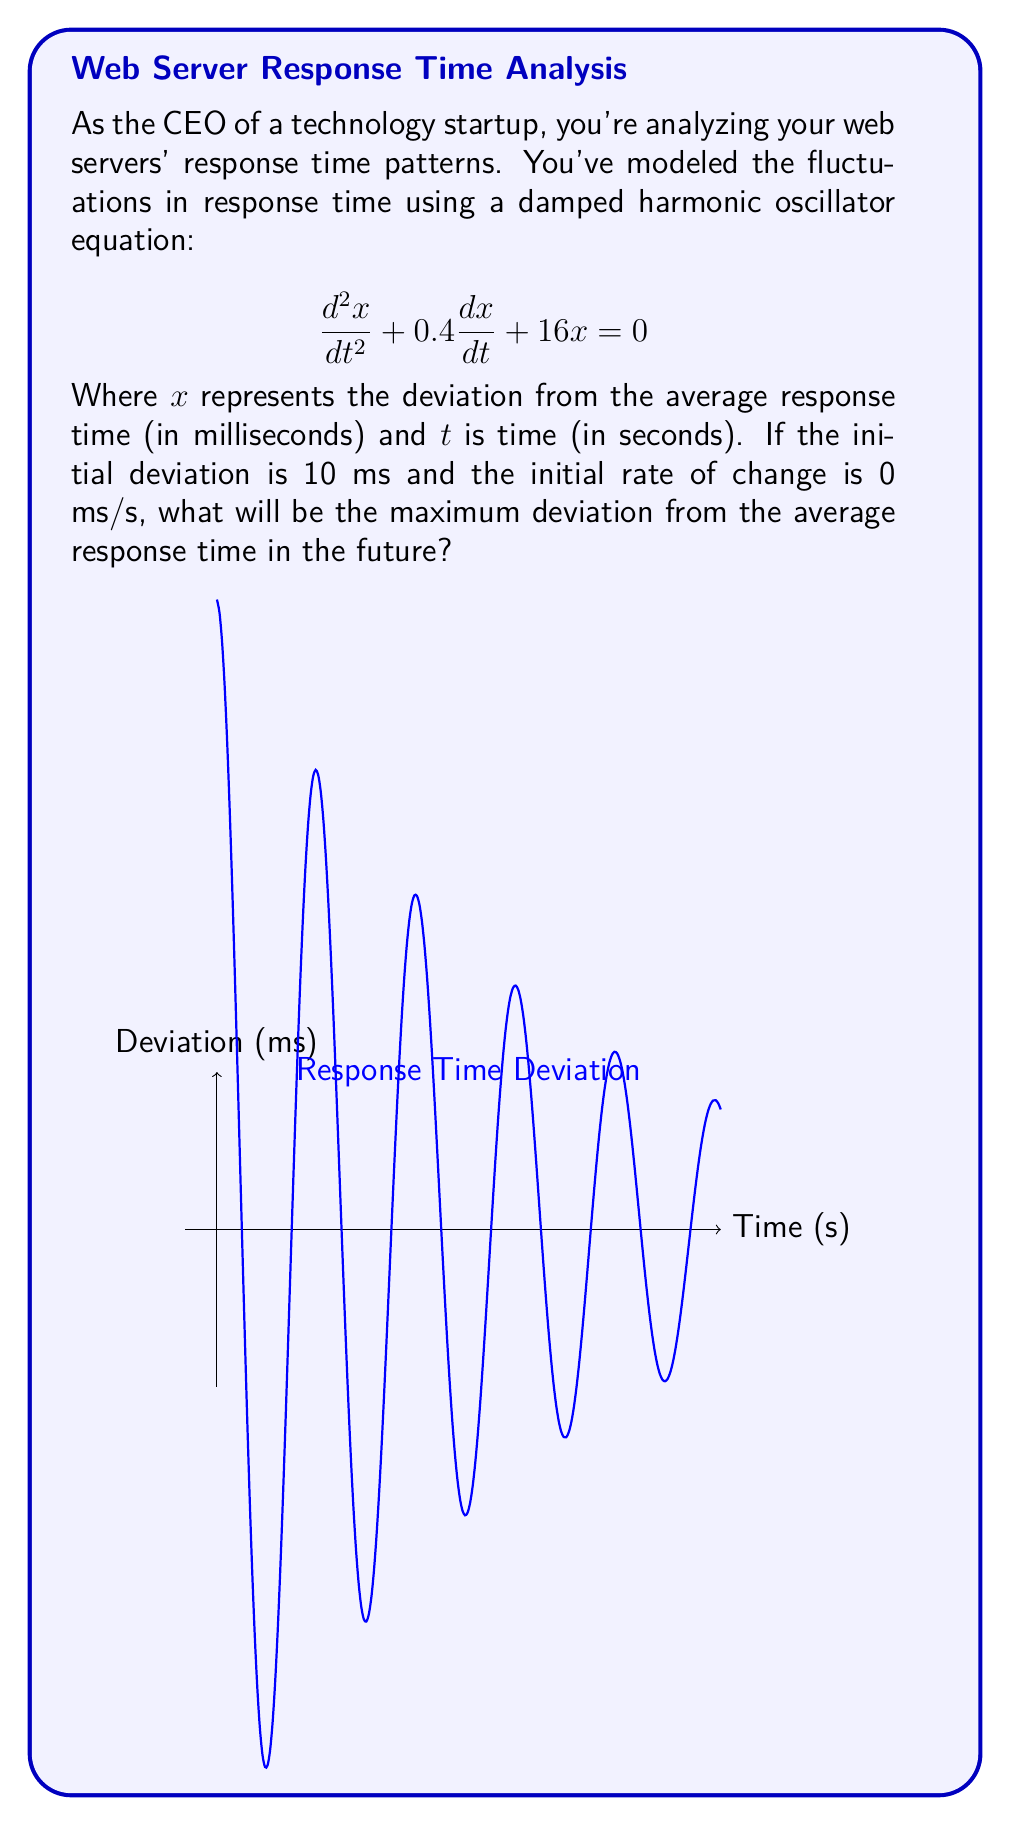Teach me how to tackle this problem. Let's approach this step-by-step:

1) The given equation is in the form of a damped harmonic oscillator:
   $$\frac{d^2x}{dt^2} + 2\beta\frac{dx}{dt} + \omega_0^2x = 0$$
   where $2\beta = 0.4$ and $\omega_0^2 = 16$.

2) For an underdamped system (which this is, as we'll see), the solution has the form:
   $$x(t) = Ae^{-\beta t}\cos(\omega t + \phi)$$
   where $\omega = \sqrt{\omega_0^2 - \beta^2}$

3) Calculate $\beta$ and $\omega$:
   $\beta = 0.2$
   $\omega = \sqrt{16 - 0.2^2} \approx 3.97$

4) Given initial conditions: $x(0) = 10$ and $x'(0) = 0$

5) Using $x(0) = 10$, we can deduce $A = 10$ and $\phi = 0$

6) Therefore, the solution is:
   $$x(t) = 10e^{-0.2t}\cos(3.97t)$$

7) The maximum deviation will occur when $\cos(3.97t) = \pm 1$, i.e., at the peaks of the oscillation.

8) The envelope of the oscillation is given by $\pm 10e^{-0.2t}$

9) The maximum future deviation will be the initial deviation, 10 ms, occurring at $t = 0$.
Answer: 10 ms 